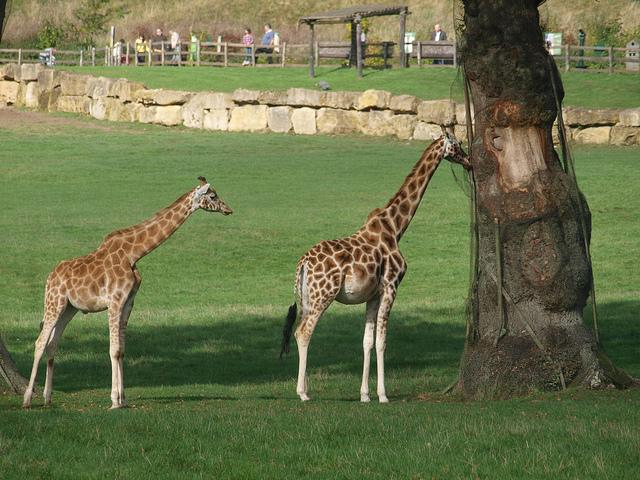What is there a giant hole taken out of the tree for? eating 